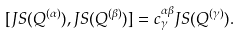Convert formula to latex. <formula><loc_0><loc_0><loc_500><loc_500>[ J S ( Q ^ { ( \alpha ) } ) , J S ( Q ^ { ( \beta ) } ) ] = c ^ { \alpha \beta } _ { \gamma } J S ( Q ^ { ( \gamma ) } ) .</formula> 